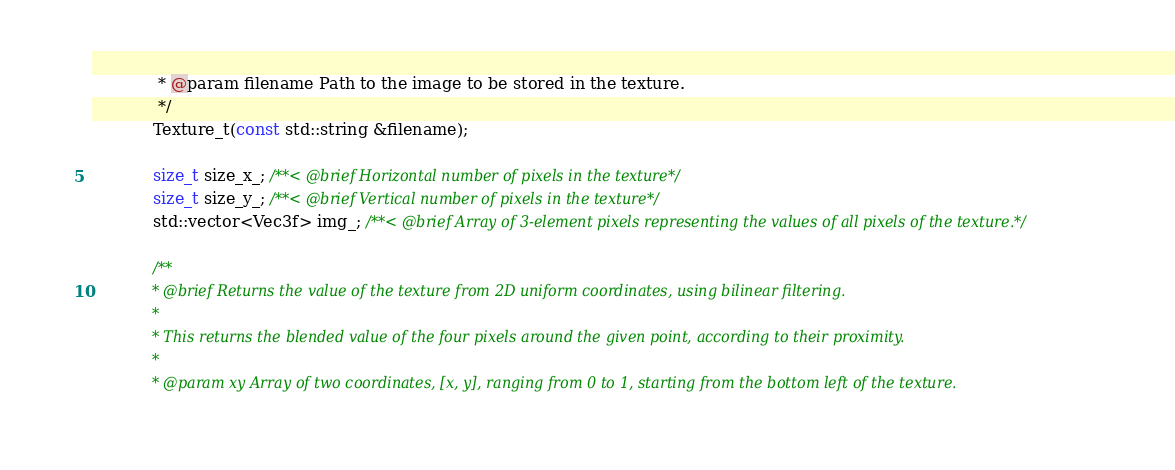<code> <loc_0><loc_0><loc_500><loc_500><_C_>             * @param filename Path to the image to be stored in the texture.
             */
            Texture_t(const std::string &filename);

            size_t size_x_; /**< @brief Horizontal number of pixels in the texture*/
            size_t size_y_; /**< @brief Vertical number of pixels in the texture*/
            std::vector<Vec3f> img_; /**< @brief Array of 3-element pixels representing the values of all pixels of the texture.*/

            /**
             * @brief Returns the value of the texture from 2D uniform coordinates, using bilinear filtering.
             * 
             * This returns the blended value of the four pixels around the given point, according to their proximity.
             * 
             * @param xy Array of two coordinates, [x, y], ranging from 0 to 1, starting from the bottom left of the texture.</code> 